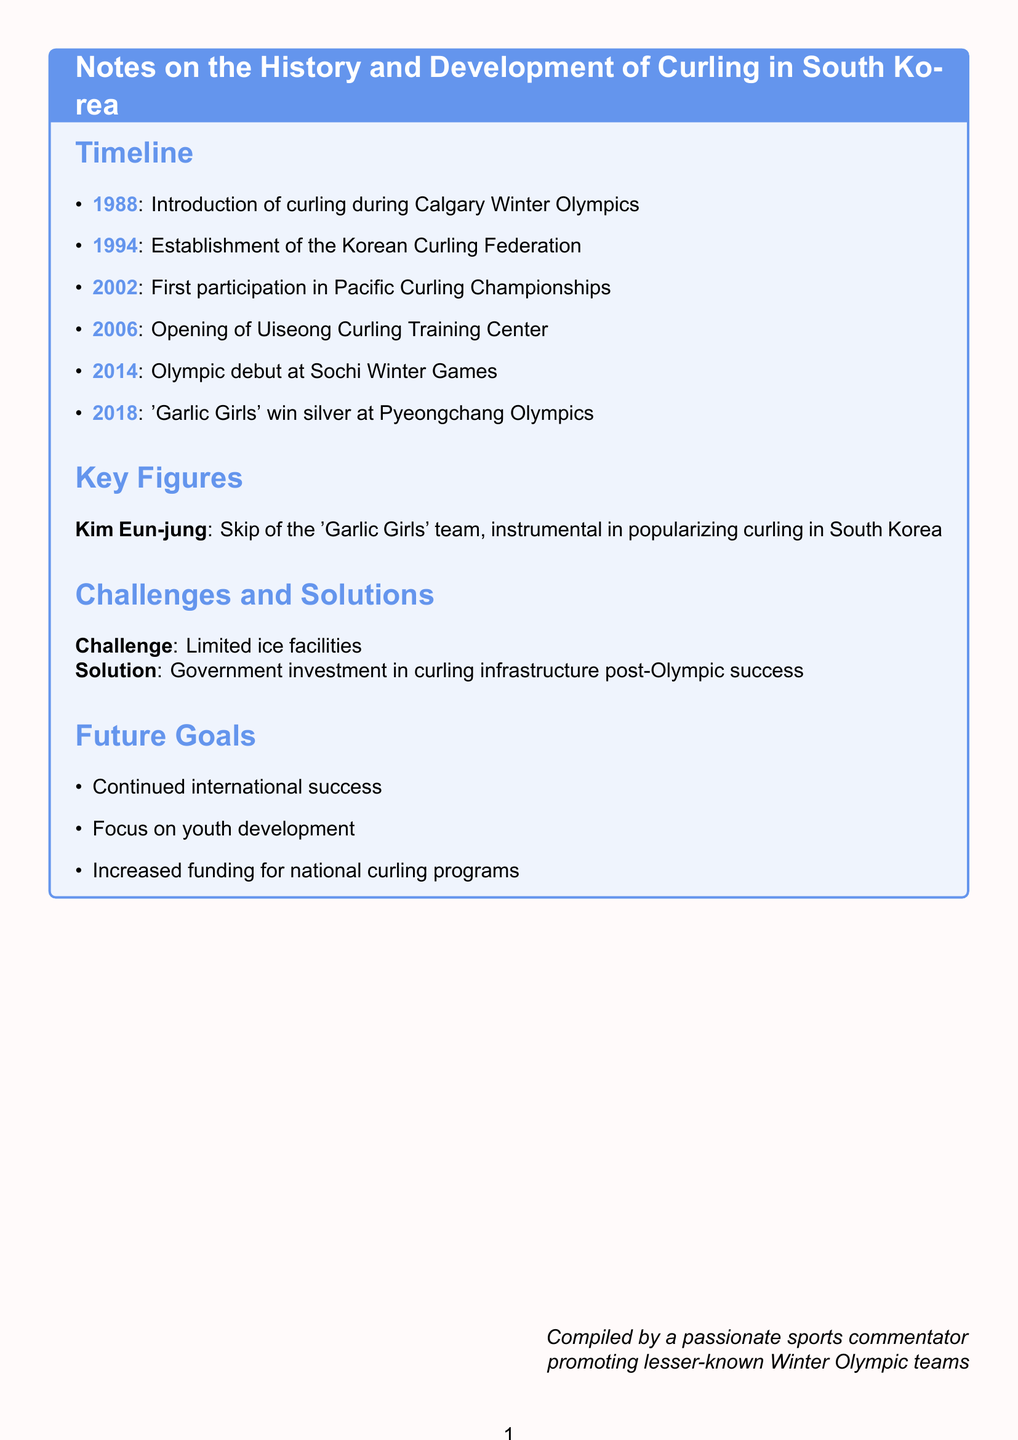What year was curling introduced to South Korea? The document states that curling was introduced in South Korea during the Calgary Winter Olympics, which is in 1988.
Answer: 1988 What is the name of the first dedicated curling facility in South Korea? The first dedicated curling facility is called the Uiseong Curling Training Center, as mentioned in the document.
Answer: Uiseong Curling Training Center In what year did South Korea's women's curling team win an Olympic silver medal? The document notes that the South Korean women's team won a silver medal at the Pyeongchang Winter Olympics in 2018.
Answer: 2018 Who was the skip of the 'Garlic Girls' team? According to the document, Kim Eun-jung was the skip of the 'Garlic Girls' team, which is highlighted in the key figures section.
Answer: Kim Eun-jung What challenge did curling face in South Korea? The document identifies limited ice facilities as a significant challenge for curling in South Korea.
Answer: Limited ice facilities What is the primary future goal for South Korean curling? The document lists continued international success as a primary future goal for South Korean curling.
Answer: Continued international success What major event marked the establishment of organized curling in South Korea? The establishment of the Korean Curling Federation in 1994 marked the official beginning of organized curling in South Korea.
Answer: Korean Curling Federation What strategy is suggested for increasing funding for national curling programs? The strategy mentioned in the document involves focusing on youth development as a means to increase funding for national curling programs.
Answer: Focus on youth development How many years passed between the introduction of curling and its first Olympic appearance by South Korea? The introduction of curling occurred in 1988, and the first Olympic appearance was in 2014, meaning 26 years passed.
Answer: 26 years 